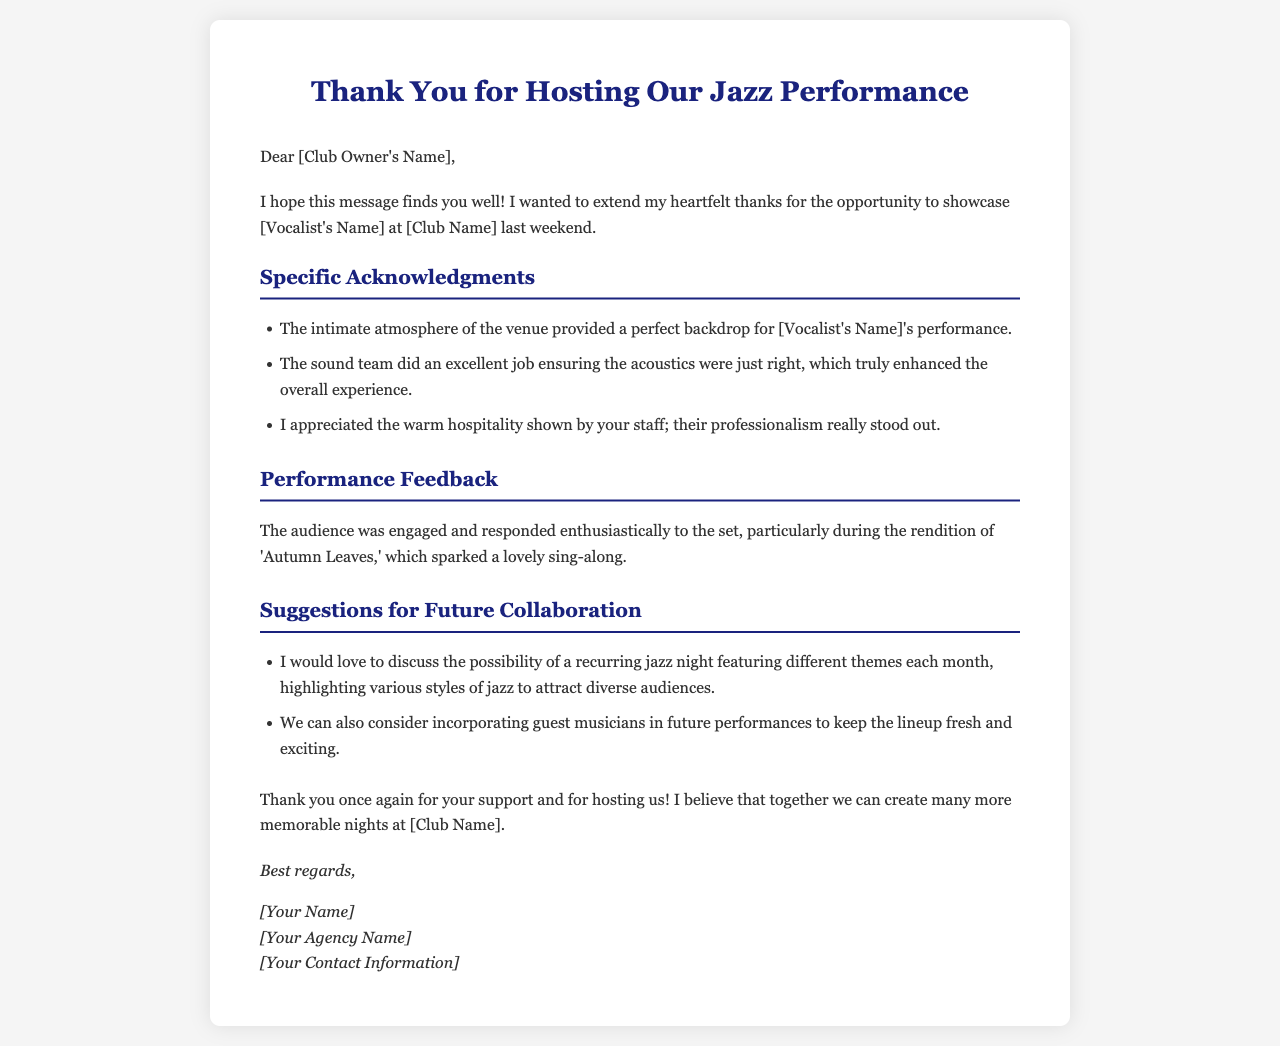what is the name of the vocalist mentioned in the letter? The vocalist's name is referenced in the letter as [Vocalist's Name].
Answer: [Vocalist's Name] who is the letter addressed to? The letter's greeting indicates it is addressed to the club owner by mentioning [Club Owner's Name].
Answer: [Club Owner's Name] what did the audience particularly enjoy during the performance? The performance feedback states that the audience engaged enthusiastically during the rendition of 'Autumn Leaves.'
Answer: 'Autumn Leaves' what is one suggestion for future collaboration mentioned in the letter? One suggestion for future collaboration includes discussing a recurring jazz night with different themes each month.
Answer: recurring jazz night how did the letter describe the atmosphere of the venue? The acknowledgments section indicates that the atmosphere of the venue was described as intimate.
Answer: intimate how many acknowledgments are listed in the letter? The letter lists three specific acknowledgments under the acknowledgments section.
Answer: three who wrote the letter? The signature of the letter indicates that it was written by [Your Name].
Answer: [Your Name] what is one quality of the sound team mentioned? The letter highlights that the sound team did an excellent job with the acoustics during the performance.
Answer: excellent job what does the closing section express gratitude for? The closing expresses gratitude for the club owner's support and for hosting the performance.
Answer: support and for hosting 